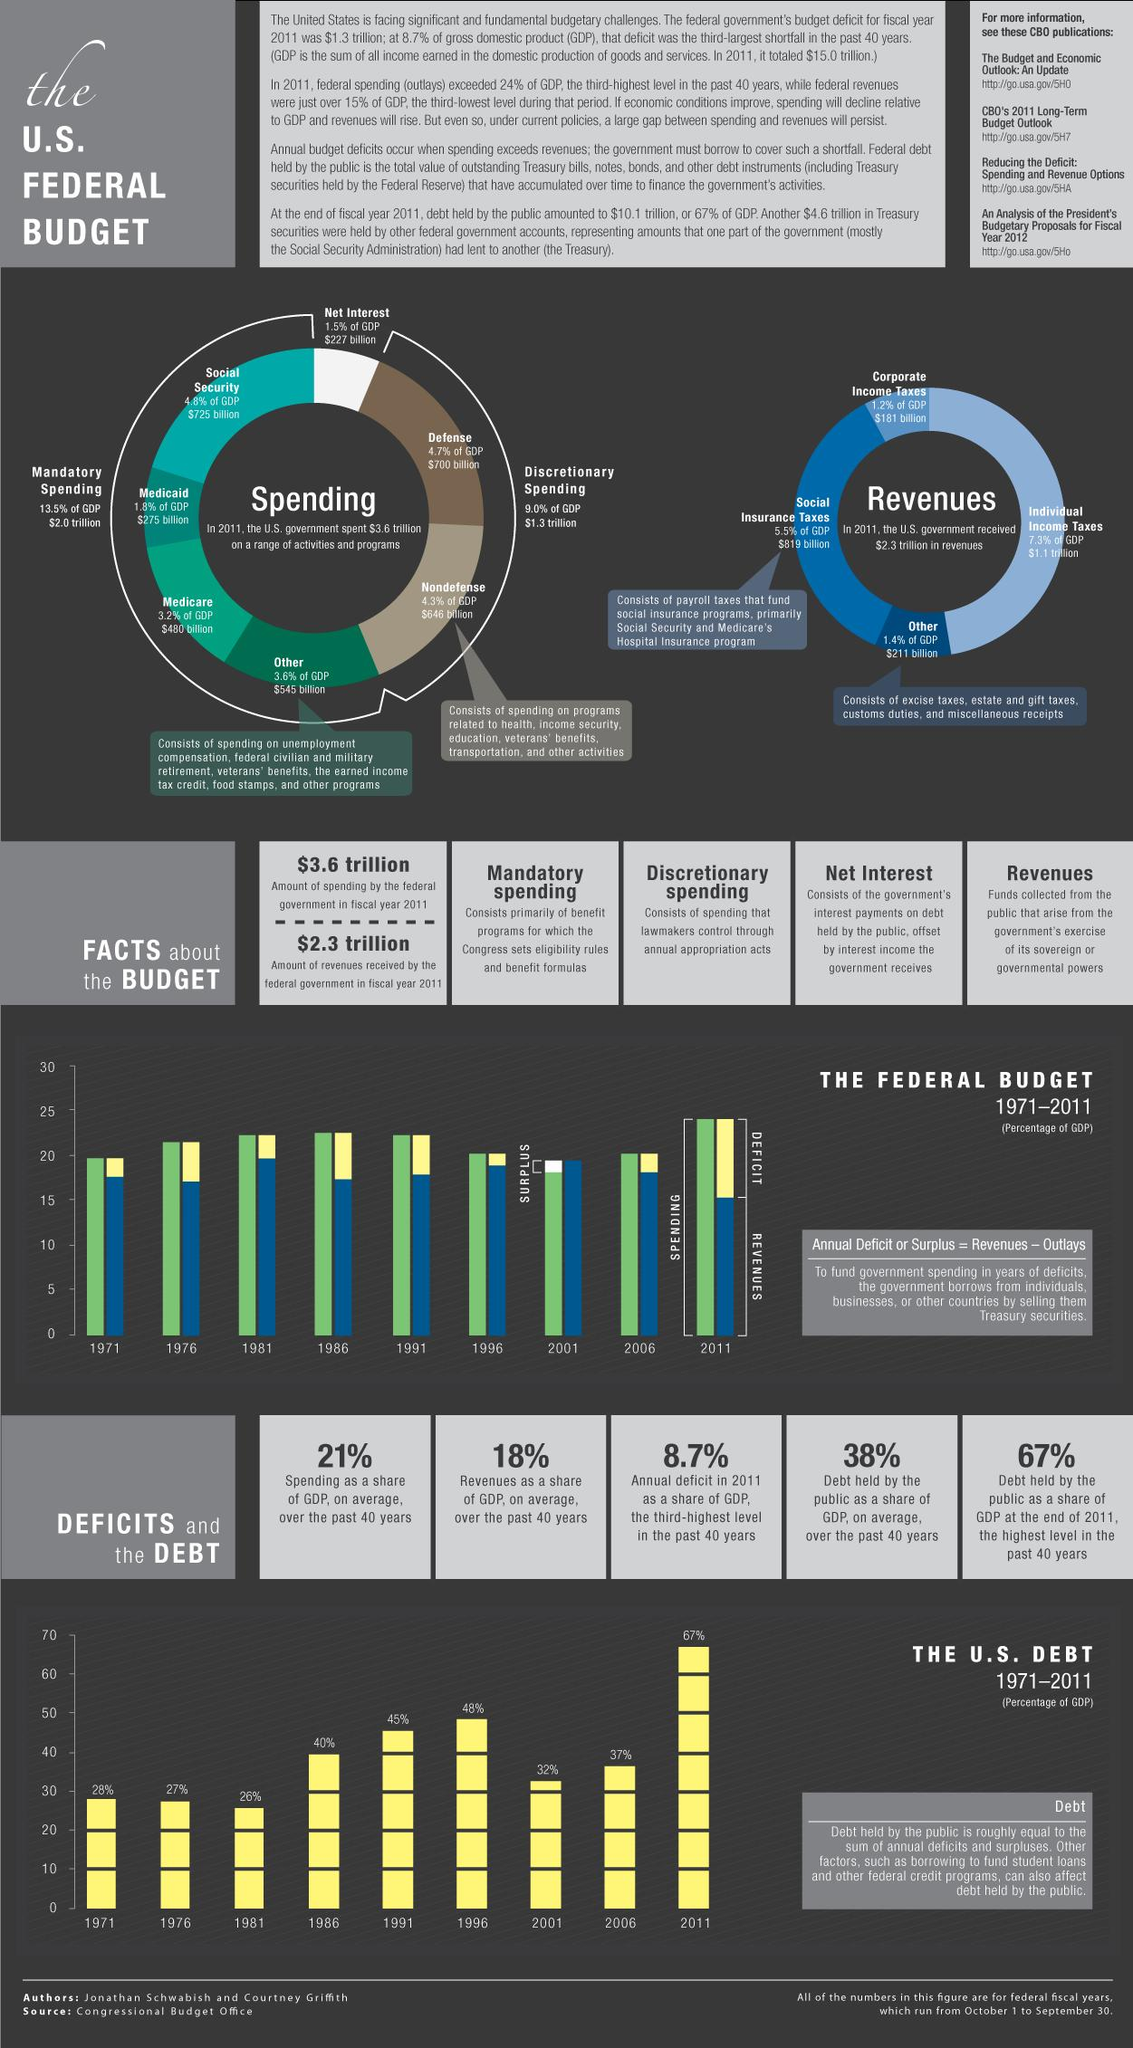Indicate a few pertinent items in this graphic. In 2011, the deficit was the highest. The amount of discretionary spending in 2011 was $1.3 trillion. Over the past 40 years, the percentage of revenues as a share of GDP has been consistently around 18%. The total amount of social insurance taxes received by the US government in 2011 was $819 billion. During the period from 1971 to 1981, the debt held by the public was consistently below 30%. Specifically, in 1971, 1976, and 1981, the debt to GDP ratio was less than 30%. 